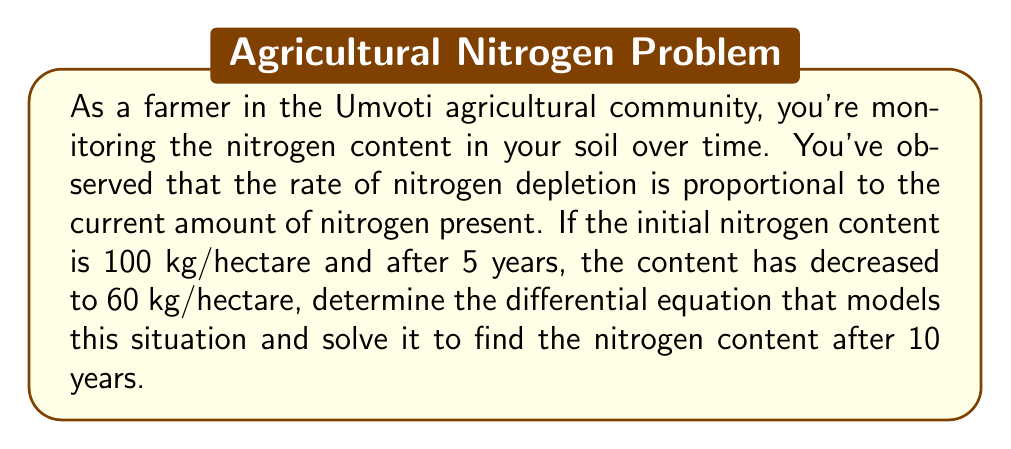Could you help me with this problem? Let's approach this step-by-step:

1) Let $N(t)$ be the amount of nitrogen (in kg/hectare) at time $t$ (in years).

2) Given that the rate of depletion is proportional to the current amount, we can write:

   $$\frac{dN}{dt} = -kN$$

   Where $k$ is a positive constant representing the rate of depletion.

3) This is a separable first-order differential equation. We can solve it as follows:

   $$\frac{dN}{N} = -k dt$$

   Integrating both sides:

   $$\int \frac{dN}{N} = -\int k dt$$

   $$\ln|N| = -kt + C$$

   $$N = Ce^{-kt}$$

   Where $C$ is a constant of integration.

4) Now, we use the initial condition: $N(0) = 100$

   $100 = Ce^{0}$
   $C = 100$

   So our solution is: $N(t) = 100e^{-kt}$

5) To find $k$, we use the condition that after 5 years, $N(5) = 60$:

   $60 = 100e^{-5k}$

   $\ln(0.6) = -5k$

   $k = -\frac{\ln(0.6)}{5} \approx 0.1022$

6) Therefore, our final equation is:

   $$N(t) = 100e^{-0.1022t}$$

7) To find the nitrogen content after 10 years, we substitute $t = 10$:

   $N(10) = 100e^{-0.1022(10)} \approx 36.03$ kg/hectare
Answer: The differential equation modeling the situation is $\frac{dN}{dt} = -kN$, where $k \approx 0.1022$. The solution is $N(t) = 100e^{-0.1022t}$. After 10 years, the nitrogen content will be approximately 36.03 kg/hectare. 